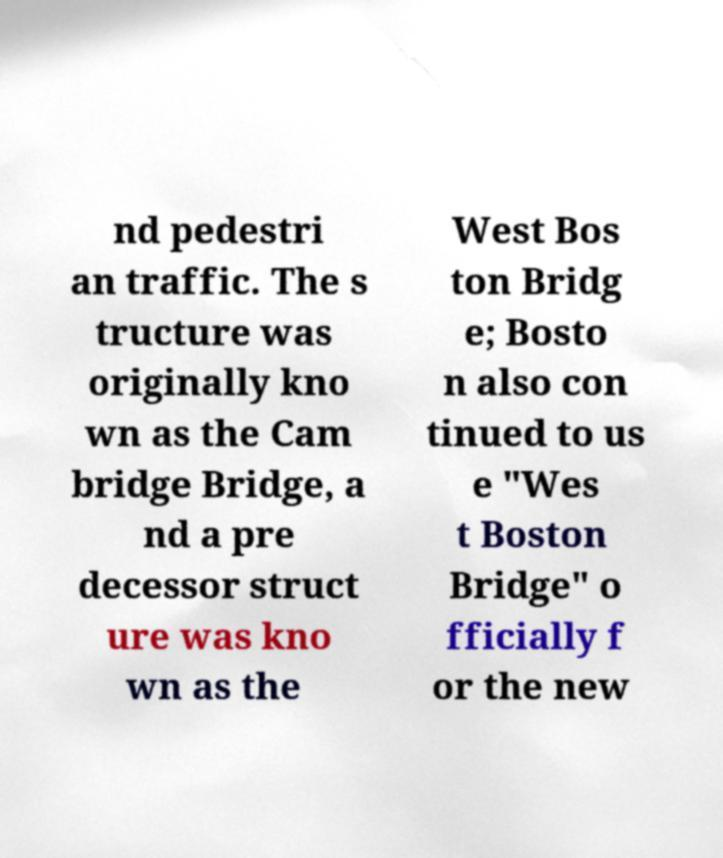Could you extract and type out the text from this image? nd pedestri an traffic. The s tructure was originally kno wn as the Cam bridge Bridge, a nd a pre decessor struct ure was kno wn as the West Bos ton Bridg e; Bosto n also con tinued to us e "Wes t Boston Bridge" o fficially f or the new 